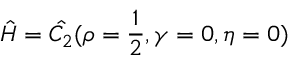<formula> <loc_0><loc_0><loc_500><loc_500>\hat { H } = \hat { C _ { 2 } } ( \rho = \frac { 1 } { 2 } , \gamma = 0 , \eta = 0 )</formula> 